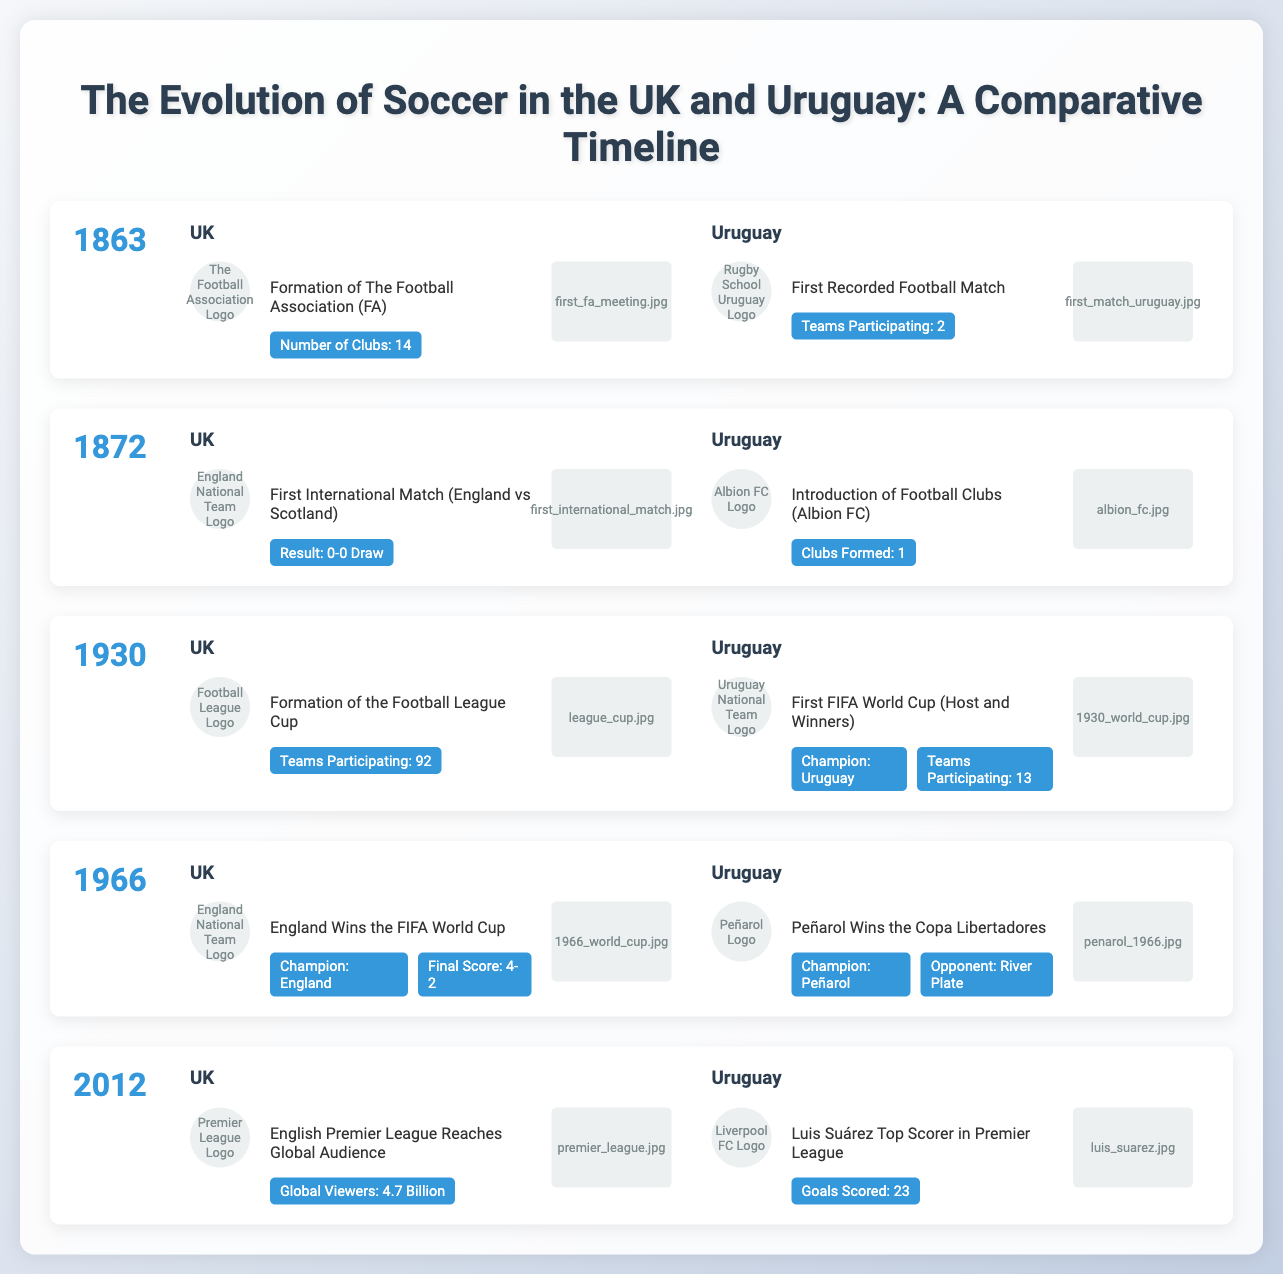What year was The Football Association formed? The Football Association (FA) was formed in 1863, as indicated in the UK section of the timeline.
Answer: 1863 What was the result of the first international match? The first international match between England and Scotland ended in a 0-0 draw, as detailed in the UK section of 1872.
Answer: 0-0 Draw What team won the first FIFA World Cup? Uruguay won the first FIFA World Cup in 1930, according to the event in the Uruguay section.
Answer: Uruguay Which year did England win the FIFA World Cup? England won the FIFA World Cup in 1966, as noted in the UK section of that year.
Answer: 1966 How many global viewers did the English Premier League reach in 2012? The document states that the English Premier League reached 4.7 billion global viewers in 2012.
Answer: 4.7 Billion Which Uruguayan player was the top scorer in the Premier League in 2012? Luis Suárez was the top scorer in the Premier League in 2012, as indicated in the Uruguay section.
Answer: Luis Suárez What is the name of the club introduced in Uruguay in 1872? The document mentions that Albion FC was established in Uruguay in 1872.
Answer: Albion FC How many teams participated in the first FIFA World Cup? The first FIFA World Cup featured 13 teams, as stated in the Uruguay section for the event of 1930.
Answer: 13 What major event occurred in the UK in 1930? The document highlights the formation of the Football League Cup in 1930 in the UK.
Answer: Formation of the Football League Cup 